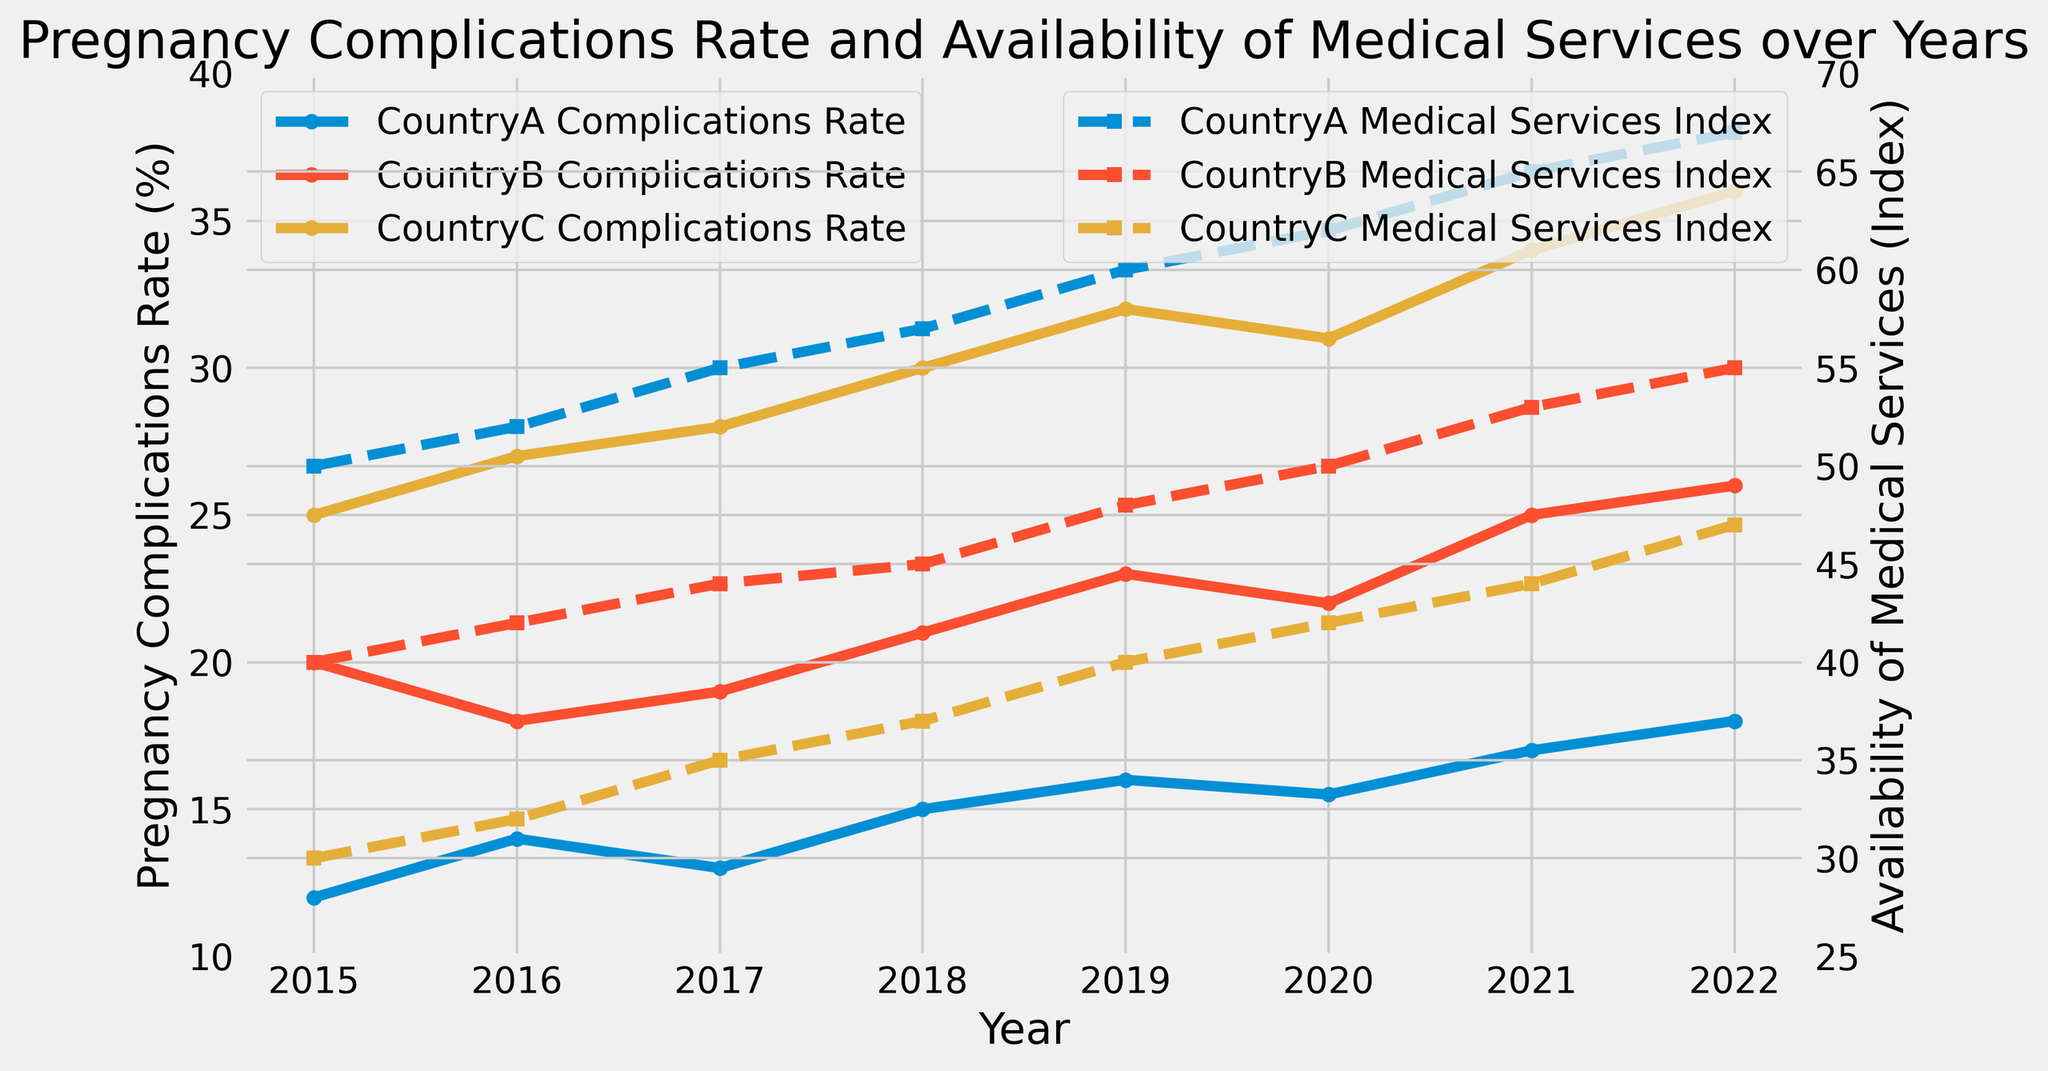What trend is observed for the pregnancy complications rate (%) in CountryA from 2015 to 2022? The figure shows that the pregnancy complications rate in CountryA starts at 12% in 2015 and gradually increases until it reaches 18% in 2022.
Answer: Increasing trend Compare the availability of medical services in CountryB and CountryC in 2018. Which country had a higher index? According to the figure, in 2018, the availability of medical services index for CountryB is at 45, while for CountryC, it is at 37.
Answer: CountryB In which year does CountryC have the highest pregnancy complications rate, and what is the corresponding rate? The figure illustrates that the highest pregnancy complications rate for CountryC is in 2022, with a rate of 36%.
Answer: 2022, 36% How does the medical services index for CountryA in 2021 compare to the index in 2015? The figure shows that the medical services index for CountryA in 2021 is 65, whereas in 2015, it was 50.
Answer: Increased by 15 What is the average pregnancy complications rate for CountryB from 2020 to 2022? The pregnancy complications rates for CountryB from 2020 to 2022 are 22%, 25%, and 26%. The average rate is calculated as (22 + 25 + 26) / 3 = 24.33%.
Answer: 24.33% Which country showed the smallest difference in pregnancy complications rate between 2015 and 2022? For CountryA, the difference is 18 - 12 = 6%. For CountryB, the difference is 26 - 20 = 6%. For CountryC, the difference is 36 - 25 = 11%. Both CountryA and CountryB have the smallest difference of 6%.
Answer: CountryA and CountryB Is there any year where CountryA and CountryB had the same pregnancy complications rate? The figure indicates that there is no such year where the pregnancy complications rates for both CountryA and CountryB are the same.
Answer: No What is the difference in the availability of medical services index between CountryA and CountryC in 2020? In 2020, the availability of medical services index for CountryA is 62, while for CountryC, it is 42. The difference is 62 - 42 = 20.
Answer: 20 